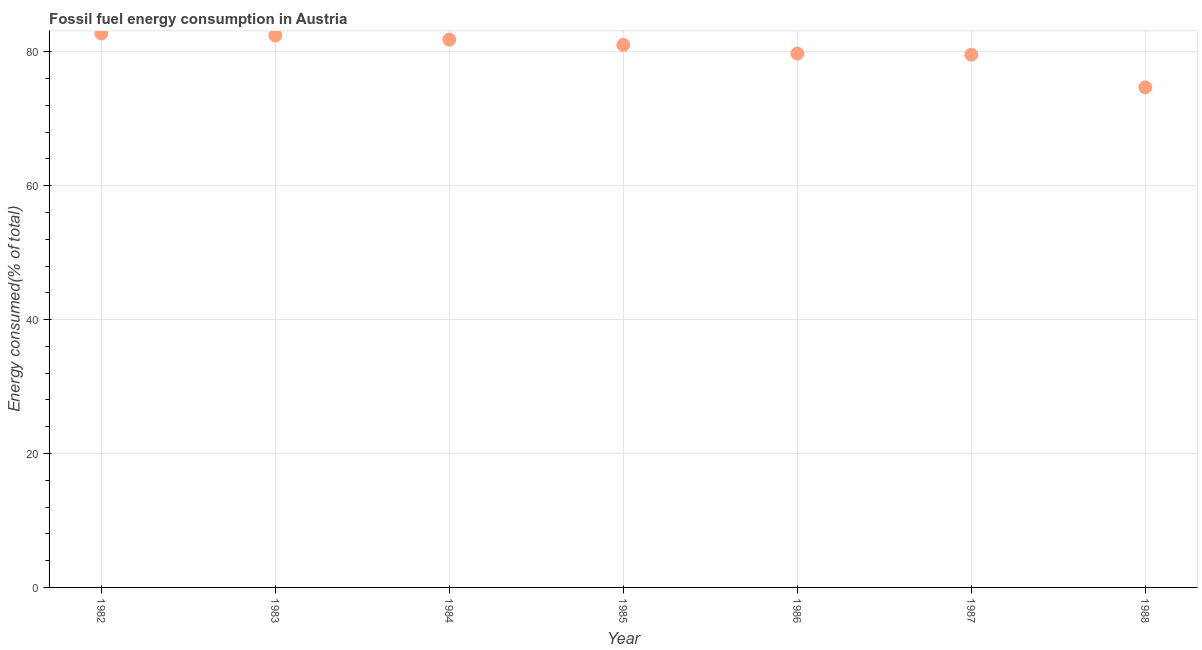What is the fossil fuel energy consumption in 1988?
Your answer should be very brief. 74.69. Across all years, what is the maximum fossil fuel energy consumption?
Offer a terse response. 82.74. Across all years, what is the minimum fossil fuel energy consumption?
Your answer should be very brief. 74.69. In which year was the fossil fuel energy consumption maximum?
Offer a very short reply. 1982. In which year was the fossil fuel energy consumption minimum?
Your answer should be compact. 1988. What is the sum of the fossil fuel energy consumption?
Your response must be concise. 562.09. What is the difference between the fossil fuel energy consumption in 1982 and 1983?
Your response must be concise. 0.3. What is the average fossil fuel energy consumption per year?
Provide a short and direct response. 80.3. What is the median fossil fuel energy consumption?
Your answer should be compact. 81.04. Do a majority of the years between 1984 and 1987 (inclusive) have fossil fuel energy consumption greater than 20 %?
Make the answer very short. Yes. What is the ratio of the fossil fuel energy consumption in 1987 to that in 1988?
Provide a succinct answer. 1.07. Is the difference between the fossil fuel energy consumption in 1985 and 1988 greater than the difference between any two years?
Offer a very short reply. No. What is the difference between the highest and the second highest fossil fuel energy consumption?
Offer a very short reply. 0.3. What is the difference between the highest and the lowest fossil fuel energy consumption?
Your answer should be compact. 8.05. Does the fossil fuel energy consumption monotonically increase over the years?
Your answer should be very brief. No. How many dotlines are there?
Provide a short and direct response. 1. How many years are there in the graph?
Ensure brevity in your answer.  7. What is the difference between two consecutive major ticks on the Y-axis?
Provide a succinct answer. 20. Are the values on the major ticks of Y-axis written in scientific E-notation?
Ensure brevity in your answer.  No. Does the graph contain grids?
Provide a succinct answer. Yes. What is the title of the graph?
Your answer should be very brief. Fossil fuel energy consumption in Austria. What is the label or title of the Y-axis?
Keep it short and to the point. Energy consumed(% of total). What is the Energy consumed(% of total) in 1982?
Provide a short and direct response. 82.74. What is the Energy consumed(% of total) in 1983?
Keep it short and to the point. 82.45. What is the Energy consumed(% of total) in 1984?
Offer a very short reply. 81.84. What is the Energy consumed(% of total) in 1985?
Keep it short and to the point. 81.04. What is the Energy consumed(% of total) in 1986?
Your response must be concise. 79.75. What is the Energy consumed(% of total) in 1987?
Give a very brief answer. 79.58. What is the Energy consumed(% of total) in 1988?
Offer a very short reply. 74.69. What is the difference between the Energy consumed(% of total) in 1982 and 1983?
Offer a very short reply. 0.3. What is the difference between the Energy consumed(% of total) in 1982 and 1984?
Provide a succinct answer. 0.91. What is the difference between the Energy consumed(% of total) in 1982 and 1985?
Make the answer very short. 1.7. What is the difference between the Energy consumed(% of total) in 1982 and 1986?
Give a very brief answer. 2.99. What is the difference between the Energy consumed(% of total) in 1982 and 1987?
Offer a terse response. 3.16. What is the difference between the Energy consumed(% of total) in 1982 and 1988?
Ensure brevity in your answer.  8.05. What is the difference between the Energy consumed(% of total) in 1983 and 1984?
Ensure brevity in your answer.  0.61. What is the difference between the Energy consumed(% of total) in 1983 and 1985?
Offer a very short reply. 1.4. What is the difference between the Energy consumed(% of total) in 1983 and 1986?
Keep it short and to the point. 2.7. What is the difference between the Energy consumed(% of total) in 1983 and 1987?
Ensure brevity in your answer.  2.87. What is the difference between the Energy consumed(% of total) in 1983 and 1988?
Give a very brief answer. 7.75. What is the difference between the Energy consumed(% of total) in 1984 and 1985?
Your answer should be compact. 0.79. What is the difference between the Energy consumed(% of total) in 1984 and 1986?
Keep it short and to the point. 2.09. What is the difference between the Energy consumed(% of total) in 1984 and 1987?
Your response must be concise. 2.26. What is the difference between the Energy consumed(% of total) in 1984 and 1988?
Keep it short and to the point. 7.14. What is the difference between the Energy consumed(% of total) in 1985 and 1986?
Keep it short and to the point. 1.29. What is the difference between the Energy consumed(% of total) in 1985 and 1987?
Ensure brevity in your answer.  1.46. What is the difference between the Energy consumed(% of total) in 1985 and 1988?
Your answer should be very brief. 6.35. What is the difference between the Energy consumed(% of total) in 1986 and 1987?
Give a very brief answer. 0.17. What is the difference between the Energy consumed(% of total) in 1986 and 1988?
Make the answer very short. 5.06. What is the difference between the Energy consumed(% of total) in 1987 and 1988?
Give a very brief answer. 4.89. What is the ratio of the Energy consumed(% of total) in 1982 to that in 1983?
Give a very brief answer. 1. What is the ratio of the Energy consumed(% of total) in 1982 to that in 1984?
Your answer should be very brief. 1.01. What is the ratio of the Energy consumed(% of total) in 1982 to that in 1986?
Your response must be concise. 1.04. What is the ratio of the Energy consumed(% of total) in 1982 to that in 1988?
Your response must be concise. 1.11. What is the ratio of the Energy consumed(% of total) in 1983 to that in 1985?
Offer a very short reply. 1.02. What is the ratio of the Energy consumed(% of total) in 1983 to that in 1986?
Provide a short and direct response. 1.03. What is the ratio of the Energy consumed(% of total) in 1983 to that in 1987?
Make the answer very short. 1.04. What is the ratio of the Energy consumed(% of total) in 1983 to that in 1988?
Keep it short and to the point. 1.1. What is the ratio of the Energy consumed(% of total) in 1984 to that in 1985?
Offer a terse response. 1.01. What is the ratio of the Energy consumed(% of total) in 1984 to that in 1986?
Provide a short and direct response. 1.03. What is the ratio of the Energy consumed(% of total) in 1984 to that in 1987?
Ensure brevity in your answer.  1.03. What is the ratio of the Energy consumed(% of total) in 1984 to that in 1988?
Your response must be concise. 1.1. What is the ratio of the Energy consumed(% of total) in 1985 to that in 1988?
Offer a terse response. 1.08. What is the ratio of the Energy consumed(% of total) in 1986 to that in 1987?
Keep it short and to the point. 1. What is the ratio of the Energy consumed(% of total) in 1986 to that in 1988?
Your response must be concise. 1.07. What is the ratio of the Energy consumed(% of total) in 1987 to that in 1988?
Provide a succinct answer. 1.06. 